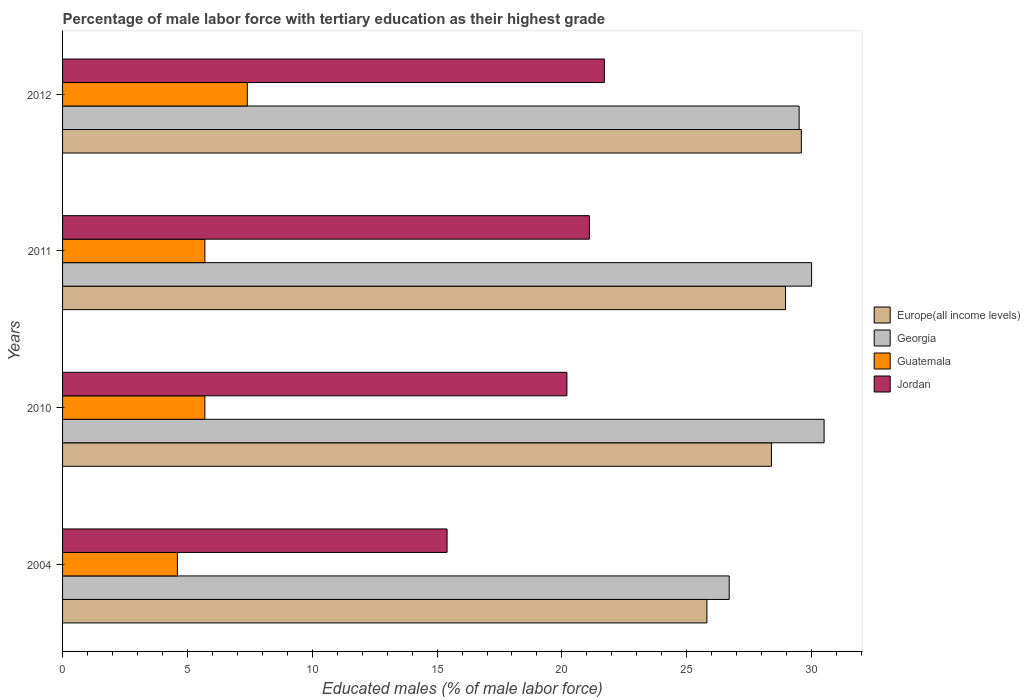How many different coloured bars are there?
Ensure brevity in your answer.  4. How many groups of bars are there?
Ensure brevity in your answer.  4. How many bars are there on the 1st tick from the top?
Offer a very short reply. 4. What is the percentage of male labor force with tertiary education in Georgia in 2011?
Keep it short and to the point. 30. Across all years, what is the maximum percentage of male labor force with tertiary education in Georgia?
Offer a terse response. 30.5. Across all years, what is the minimum percentage of male labor force with tertiary education in Guatemala?
Offer a very short reply. 4.6. In which year was the percentage of male labor force with tertiary education in Jordan maximum?
Offer a terse response. 2012. What is the total percentage of male labor force with tertiary education in Georgia in the graph?
Provide a succinct answer. 116.7. What is the difference between the percentage of male labor force with tertiary education in Georgia in 2004 and that in 2011?
Offer a terse response. -3.3. What is the difference between the percentage of male labor force with tertiary education in Georgia in 2010 and the percentage of male labor force with tertiary education in Guatemala in 2011?
Keep it short and to the point. 24.8. What is the average percentage of male labor force with tertiary education in Europe(all income levels) per year?
Provide a short and direct response. 28.19. In the year 2010, what is the difference between the percentage of male labor force with tertiary education in Europe(all income levels) and percentage of male labor force with tertiary education in Guatemala?
Provide a succinct answer. 22.69. In how many years, is the percentage of male labor force with tertiary education in Jordan greater than 24 %?
Make the answer very short. 0. What is the ratio of the percentage of male labor force with tertiary education in Jordan in 2010 to that in 2011?
Provide a short and direct response. 0.96. Is the difference between the percentage of male labor force with tertiary education in Europe(all income levels) in 2004 and 2012 greater than the difference between the percentage of male labor force with tertiary education in Guatemala in 2004 and 2012?
Give a very brief answer. No. What is the difference between the highest and the second highest percentage of male labor force with tertiary education in Jordan?
Make the answer very short. 0.6. What is the difference between the highest and the lowest percentage of male labor force with tertiary education in Georgia?
Give a very brief answer. 3.8. In how many years, is the percentage of male labor force with tertiary education in Guatemala greater than the average percentage of male labor force with tertiary education in Guatemala taken over all years?
Provide a short and direct response. 1. What does the 1st bar from the top in 2004 represents?
Give a very brief answer. Jordan. What does the 3rd bar from the bottom in 2004 represents?
Offer a terse response. Guatemala. Is it the case that in every year, the sum of the percentage of male labor force with tertiary education in Guatemala and percentage of male labor force with tertiary education in Jordan is greater than the percentage of male labor force with tertiary education in Europe(all income levels)?
Provide a short and direct response. No. What is the difference between two consecutive major ticks on the X-axis?
Keep it short and to the point. 5. Are the values on the major ticks of X-axis written in scientific E-notation?
Give a very brief answer. No. Does the graph contain any zero values?
Ensure brevity in your answer.  No. Does the graph contain grids?
Give a very brief answer. No. What is the title of the graph?
Offer a terse response. Percentage of male labor force with tertiary education as their highest grade. What is the label or title of the X-axis?
Your answer should be very brief. Educated males (% of male labor force). What is the Educated males (% of male labor force) of Europe(all income levels) in 2004?
Make the answer very short. 25.81. What is the Educated males (% of male labor force) of Georgia in 2004?
Ensure brevity in your answer.  26.7. What is the Educated males (% of male labor force) of Guatemala in 2004?
Provide a short and direct response. 4.6. What is the Educated males (% of male labor force) in Jordan in 2004?
Provide a short and direct response. 15.4. What is the Educated males (% of male labor force) of Europe(all income levels) in 2010?
Provide a short and direct response. 28.39. What is the Educated males (% of male labor force) of Georgia in 2010?
Ensure brevity in your answer.  30.5. What is the Educated males (% of male labor force) in Guatemala in 2010?
Give a very brief answer. 5.7. What is the Educated males (% of male labor force) of Jordan in 2010?
Offer a terse response. 20.2. What is the Educated males (% of male labor force) in Europe(all income levels) in 2011?
Offer a very short reply. 28.96. What is the Educated males (% of male labor force) in Georgia in 2011?
Your answer should be compact. 30. What is the Educated males (% of male labor force) of Guatemala in 2011?
Your answer should be very brief. 5.7. What is the Educated males (% of male labor force) in Jordan in 2011?
Offer a terse response. 21.1. What is the Educated males (% of male labor force) in Europe(all income levels) in 2012?
Your answer should be compact. 29.59. What is the Educated males (% of male labor force) in Georgia in 2012?
Ensure brevity in your answer.  29.5. What is the Educated males (% of male labor force) of Guatemala in 2012?
Make the answer very short. 7.4. What is the Educated males (% of male labor force) in Jordan in 2012?
Give a very brief answer. 21.7. Across all years, what is the maximum Educated males (% of male labor force) in Europe(all income levels)?
Keep it short and to the point. 29.59. Across all years, what is the maximum Educated males (% of male labor force) in Georgia?
Your answer should be very brief. 30.5. Across all years, what is the maximum Educated males (% of male labor force) of Guatemala?
Provide a short and direct response. 7.4. Across all years, what is the maximum Educated males (% of male labor force) of Jordan?
Your response must be concise. 21.7. Across all years, what is the minimum Educated males (% of male labor force) of Europe(all income levels)?
Make the answer very short. 25.81. Across all years, what is the minimum Educated males (% of male labor force) of Georgia?
Your answer should be very brief. 26.7. Across all years, what is the minimum Educated males (% of male labor force) of Guatemala?
Your response must be concise. 4.6. Across all years, what is the minimum Educated males (% of male labor force) of Jordan?
Provide a succinct answer. 15.4. What is the total Educated males (% of male labor force) in Europe(all income levels) in the graph?
Make the answer very short. 112.75. What is the total Educated males (% of male labor force) in Georgia in the graph?
Offer a very short reply. 116.7. What is the total Educated males (% of male labor force) of Guatemala in the graph?
Make the answer very short. 23.4. What is the total Educated males (% of male labor force) in Jordan in the graph?
Give a very brief answer. 78.4. What is the difference between the Educated males (% of male labor force) in Europe(all income levels) in 2004 and that in 2010?
Ensure brevity in your answer.  -2.58. What is the difference between the Educated males (% of male labor force) of Jordan in 2004 and that in 2010?
Provide a succinct answer. -4.8. What is the difference between the Educated males (% of male labor force) in Europe(all income levels) in 2004 and that in 2011?
Your answer should be compact. -3.15. What is the difference between the Educated males (% of male labor force) of Georgia in 2004 and that in 2011?
Ensure brevity in your answer.  -3.3. What is the difference between the Educated males (% of male labor force) of Guatemala in 2004 and that in 2011?
Your response must be concise. -1.1. What is the difference between the Educated males (% of male labor force) of Jordan in 2004 and that in 2011?
Make the answer very short. -5.7. What is the difference between the Educated males (% of male labor force) of Europe(all income levels) in 2004 and that in 2012?
Keep it short and to the point. -3.78. What is the difference between the Educated males (% of male labor force) of Georgia in 2004 and that in 2012?
Provide a succinct answer. -2.8. What is the difference between the Educated males (% of male labor force) in Europe(all income levels) in 2010 and that in 2011?
Your answer should be compact. -0.57. What is the difference between the Educated males (% of male labor force) of Europe(all income levels) in 2010 and that in 2012?
Your response must be concise. -1.2. What is the difference between the Educated males (% of male labor force) of Georgia in 2010 and that in 2012?
Make the answer very short. 1. What is the difference between the Educated males (% of male labor force) in Jordan in 2010 and that in 2012?
Your answer should be very brief. -1.5. What is the difference between the Educated males (% of male labor force) in Europe(all income levels) in 2011 and that in 2012?
Make the answer very short. -0.63. What is the difference between the Educated males (% of male labor force) of Guatemala in 2011 and that in 2012?
Ensure brevity in your answer.  -1.7. What is the difference between the Educated males (% of male labor force) in Europe(all income levels) in 2004 and the Educated males (% of male labor force) in Georgia in 2010?
Make the answer very short. -4.69. What is the difference between the Educated males (% of male labor force) in Europe(all income levels) in 2004 and the Educated males (% of male labor force) in Guatemala in 2010?
Your answer should be compact. 20.11. What is the difference between the Educated males (% of male labor force) in Europe(all income levels) in 2004 and the Educated males (% of male labor force) in Jordan in 2010?
Your answer should be compact. 5.61. What is the difference between the Educated males (% of male labor force) of Georgia in 2004 and the Educated males (% of male labor force) of Guatemala in 2010?
Offer a very short reply. 21. What is the difference between the Educated males (% of male labor force) in Georgia in 2004 and the Educated males (% of male labor force) in Jordan in 2010?
Your answer should be very brief. 6.5. What is the difference between the Educated males (% of male labor force) of Guatemala in 2004 and the Educated males (% of male labor force) of Jordan in 2010?
Your answer should be compact. -15.6. What is the difference between the Educated males (% of male labor force) of Europe(all income levels) in 2004 and the Educated males (% of male labor force) of Georgia in 2011?
Make the answer very short. -4.19. What is the difference between the Educated males (% of male labor force) in Europe(all income levels) in 2004 and the Educated males (% of male labor force) in Guatemala in 2011?
Your answer should be very brief. 20.11. What is the difference between the Educated males (% of male labor force) in Europe(all income levels) in 2004 and the Educated males (% of male labor force) in Jordan in 2011?
Your response must be concise. 4.71. What is the difference between the Educated males (% of male labor force) of Georgia in 2004 and the Educated males (% of male labor force) of Guatemala in 2011?
Make the answer very short. 21. What is the difference between the Educated males (% of male labor force) in Guatemala in 2004 and the Educated males (% of male labor force) in Jordan in 2011?
Your response must be concise. -16.5. What is the difference between the Educated males (% of male labor force) in Europe(all income levels) in 2004 and the Educated males (% of male labor force) in Georgia in 2012?
Give a very brief answer. -3.69. What is the difference between the Educated males (% of male labor force) of Europe(all income levels) in 2004 and the Educated males (% of male labor force) of Guatemala in 2012?
Ensure brevity in your answer.  18.41. What is the difference between the Educated males (% of male labor force) in Europe(all income levels) in 2004 and the Educated males (% of male labor force) in Jordan in 2012?
Keep it short and to the point. 4.11. What is the difference between the Educated males (% of male labor force) of Georgia in 2004 and the Educated males (% of male labor force) of Guatemala in 2012?
Your answer should be compact. 19.3. What is the difference between the Educated males (% of male labor force) of Georgia in 2004 and the Educated males (% of male labor force) of Jordan in 2012?
Make the answer very short. 5. What is the difference between the Educated males (% of male labor force) of Guatemala in 2004 and the Educated males (% of male labor force) of Jordan in 2012?
Provide a succinct answer. -17.1. What is the difference between the Educated males (% of male labor force) of Europe(all income levels) in 2010 and the Educated males (% of male labor force) of Georgia in 2011?
Make the answer very short. -1.61. What is the difference between the Educated males (% of male labor force) of Europe(all income levels) in 2010 and the Educated males (% of male labor force) of Guatemala in 2011?
Keep it short and to the point. 22.69. What is the difference between the Educated males (% of male labor force) of Europe(all income levels) in 2010 and the Educated males (% of male labor force) of Jordan in 2011?
Offer a terse response. 7.29. What is the difference between the Educated males (% of male labor force) in Georgia in 2010 and the Educated males (% of male labor force) in Guatemala in 2011?
Ensure brevity in your answer.  24.8. What is the difference between the Educated males (% of male labor force) in Guatemala in 2010 and the Educated males (% of male labor force) in Jordan in 2011?
Make the answer very short. -15.4. What is the difference between the Educated males (% of male labor force) of Europe(all income levels) in 2010 and the Educated males (% of male labor force) of Georgia in 2012?
Ensure brevity in your answer.  -1.11. What is the difference between the Educated males (% of male labor force) in Europe(all income levels) in 2010 and the Educated males (% of male labor force) in Guatemala in 2012?
Offer a very short reply. 20.99. What is the difference between the Educated males (% of male labor force) in Europe(all income levels) in 2010 and the Educated males (% of male labor force) in Jordan in 2012?
Your answer should be compact. 6.69. What is the difference between the Educated males (% of male labor force) of Georgia in 2010 and the Educated males (% of male labor force) of Guatemala in 2012?
Your answer should be very brief. 23.1. What is the difference between the Educated males (% of male labor force) in Georgia in 2010 and the Educated males (% of male labor force) in Jordan in 2012?
Provide a succinct answer. 8.8. What is the difference between the Educated males (% of male labor force) in Europe(all income levels) in 2011 and the Educated males (% of male labor force) in Georgia in 2012?
Your answer should be compact. -0.54. What is the difference between the Educated males (% of male labor force) in Europe(all income levels) in 2011 and the Educated males (% of male labor force) in Guatemala in 2012?
Your answer should be very brief. 21.56. What is the difference between the Educated males (% of male labor force) of Europe(all income levels) in 2011 and the Educated males (% of male labor force) of Jordan in 2012?
Make the answer very short. 7.26. What is the difference between the Educated males (% of male labor force) in Georgia in 2011 and the Educated males (% of male labor force) in Guatemala in 2012?
Give a very brief answer. 22.6. What is the difference between the Educated males (% of male labor force) in Georgia in 2011 and the Educated males (% of male labor force) in Jordan in 2012?
Offer a very short reply. 8.3. What is the difference between the Educated males (% of male labor force) in Guatemala in 2011 and the Educated males (% of male labor force) in Jordan in 2012?
Your response must be concise. -16. What is the average Educated males (% of male labor force) in Europe(all income levels) per year?
Provide a short and direct response. 28.19. What is the average Educated males (% of male labor force) in Georgia per year?
Your answer should be very brief. 29.18. What is the average Educated males (% of male labor force) in Guatemala per year?
Provide a succinct answer. 5.85. What is the average Educated males (% of male labor force) in Jordan per year?
Your answer should be very brief. 19.6. In the year 2004, what is the difference between the Educated males (% of male labor force) in Europe(all income levels) and Educated males (% of male labor force) in Georgia?
Offer a terse response. -0.89. In the year 2004, what is the difference between the Educated males (% of male labor force) of Europe(all income levels) and Educated males (% of male labor force) of Guatemala?
Your answer should be compact. 21.21. In the year 2004, what is the difference between the Educated males (% of male labor force) in Europe(all income levels) and Educated males (% of male labor force) in Jordan?
Your answer should be compact. 10.41. In the year 2004, what is the difference between the Educated males (% of male labor force) of Georgia and Educated males (% of male labor force) of Guatemala?
Provide a short and direct response. 22.1. In the year 2004, what is the difference between the Educated males (% of male labor force) in Georgia and Educated males (% of male labor force) in Jordan?
Give a very brief answer. 11.3. In the year 2004, what is the difference between the Educated males (% of male labor force) of Guatemala and Educated males (% of male labor force) of Jordan?
Provide a succinct answer. -10.8. In the year 2010, what is the difference between the Educated males (% of male labor force) in Europe(all income levels) and Educated males (% of male labor force) in Georgia?
Provide a succinct answer. -2.11. In the year 2010, what is the difference between the Educated males (% of male labor force) in Europe(all income levels) and Educated males (% of male labor force) in Guatemala?
Ensure brevity in your answer.  22.69. In the year 2010, what is the difference between the Educated males (% of male labor force) in Europe(all income levels) and Educated males (% of male labor force) in Jordan?
Offer a very short reply. 8.19. In the year 2010, what is the difference between the Educated males (% of male labor force) in Georgia and Educated males (% of male labor force) in Guatemala?
Your response must be concise. 24.8. In the year 2011, what is the difference between the Educated males (% of male labor force) in Europe(all income levels) and Educated males (% of male labor force) in Georgia?
Keep it short and to the point. -1.04. In the year 2011, what is the difference between the Educated males (% of male labor force) of Europe(all income levels) and Educated males (% of male labor force) of Guatemala?
Provide a short and direct response. 23.26. In the year 2011, what is the difference between the Educated males (% of male labor force) in Europe(all income levels) and Educated males (% of male labor force) in Jordan?
Your answer should be compact. 7.86. In the year 2011, what is the difference between the Educated males (% of male labor force) of Georgia and Educated males (% of male labor force) of Guatemala?
Offer a very short reply. 24.3. In the year 2011, what is the difference between the Educated males (% of male labor force) of Georgia and Educated males (% of male labor force) of Jordan?
Your answer should be compact. 8.9. In the year 2011, what is the difference between the Educated males (% of male labor force) of Guatemala and Educated males (% of male labor force) of Jordan?
Offer a very short reply. -15.4. In the year 2012, what is the difference between the Educated males (% of male labor force) in Europe(all income levels) and Educated males (% of male labor force) in Georgia?
Provide a short and direct response. 0.09. In the year 2012, what is the difference between the Educated males (% of male labor force) in Europe(all income levels) and Educated males (% of male labor force) in Guatemala?
Keep it short and to the point. 22.19. In the year 2012, what is the difference between the Educated males (% of male labor force) of Europe(all income levels) and Educated males (% of male labor force) of Jordan?
Keep it short and to the point. 7.89. In the year 2012, what is the difference between the Educated males (% of male labor force) of Georgia and Educated males (% of male labor force) of Guatemala?
Keep it short and to the point. 22.1. In the year 2012, what is the difference between the Educated males (% of male labor force) in Georgia and Educated males (% of male labor force) in Jordan?
Make the answer very short. 7.8. In the year 2012, what is the difference between the Educated males (% of male labor force) in Guatemala and Educated males (% of male labor force) in Jordan?
Ensure brevity in your answer.  -14.3. What is the ratio of the Educated males (% of male labor force) of Europe(all income levels) in 2004 to that in 2010?
Offer a terse response. 0.91. What is the ratio of the Educated males (% of male labor force) of Georgia in 2004 to that in 2010?
Offer a very short reply. 0.88. What is the ratio of the Educated males (% of male labor force) in Guatemala in 2004 to that in 2010?
Ensure brevity in your answer.  0.81. What is the ratio of the Educated males (% of male labor force) of Jordan in 2004 to that in 2010?
Ensure brevity in your answer.  0.76. What is the ratio of the Educated males (% of male labor force) of Europe(all income levels) in 2004 to that in 2011?
Your answer should be very brief. 0.89. What is the ratio of the Educated males (% of male labor force) in Georgia in 2004 to that in 2011?
Make the answer very short. 0.89. What is the ratio of the Educated males (% of male labor force) of Guatemala in 2004 to that in 2011?
Your answer should be very brief. 0.81. What is the ratio of the Educated males (% of male labor force) in Jordan in 2004 to that in 2011?
Your answer should be very brief. 0.73. What is the ratio of the Educated males (% of male labor force) of Europe(all income levels) in 2004 to that in 2012?
Keep it short and to the point. 0.87. What is the ratio of the Educated males (% of male labor force) in Georgia in 2004 to that in 2012?
Your answer should be compact. 0.91. What is the ratio of the Educated males (% of male labor force) of Guatemala in 2004 to that in 2012?
Ensure brevity in your answer.  0.62. What is the ratio of the Educated males (% of male labor force) in Jordan in 2004 to that in 2012?
Your answer should be compact. 0.71. What is the ratio of the Educated males (% of male labor force) of Europe(all income levels) in 2010 to that in 2011?
Offer a terse response. 0.98. What is the ratio of the Educated males (% of male labor force) of Georgia in 2010 to that in 2011?
Make the answer very short. 1.02. What is the ratio of the Educated males (% of male labor force) in Guatemala in 2010 to that in 2011?
Provide a succinct answer. 1. What is the ratio of the Educated males (% of male labor force) of Jordan in 2010 to that in 2011?
Provide a succinct answer. 0.96. What is the ratio of the Educated males (% of male labor force) of Europe(all income levels) in 2010 to that in 2012?
Keep it short and to the point. 0.96. What is the ratio of the Educated males (% of male labor force) in Georgia in 2010 to that in 2012?
Ensure brevity in your answer.  1.03. What is the ratio of the Educated males (% of male labor force) of Guatemala in 2010 to that in 2012?
Make the answer very short. 0.77. What is the ratio of the Educated males (% of male labor force) of Jordan in 2010 to that in 2012?
Ensure brevity in your answer.  0.93. What is the ratio of the Educated males (% of male labor force) in Europe(all income levels) in 2011 to that in 2012?
Your answer should be very brief. 0.98. What is the ratio of the Educated males (% of male labor force) of Georgia in 2011 to that in 2012?
Ensure brevity in your answer.  1.02. What is the ratio of the Educated males (% of male labor force) in Guatemala in 2011 to that in 2012?
Make the answer very short. 0.77. What is the ratio of the Educated males (% of male labor force) of Jordan in 2011 to that in 2012?
Give a very brief answer. 0.97. What is the difference between the highest and the second highest Educated males (% of male labor force) of Europe(all income levels)?
Your answer should be compact. 0.63. What is the difference between the highest and the second highest Educated males (% of male labor force) of Jordan?
Keep it short and to the point. 0.6. What is the difference between the highest and the lowest Educated males (% of male labor force) of Europe(all income levels)?
Offer a terse response. 3.78. What is the difference between the highest and the lowest Educated males (% of male labor force) in Georgia?
Your answer should be very brief. 3.8. 